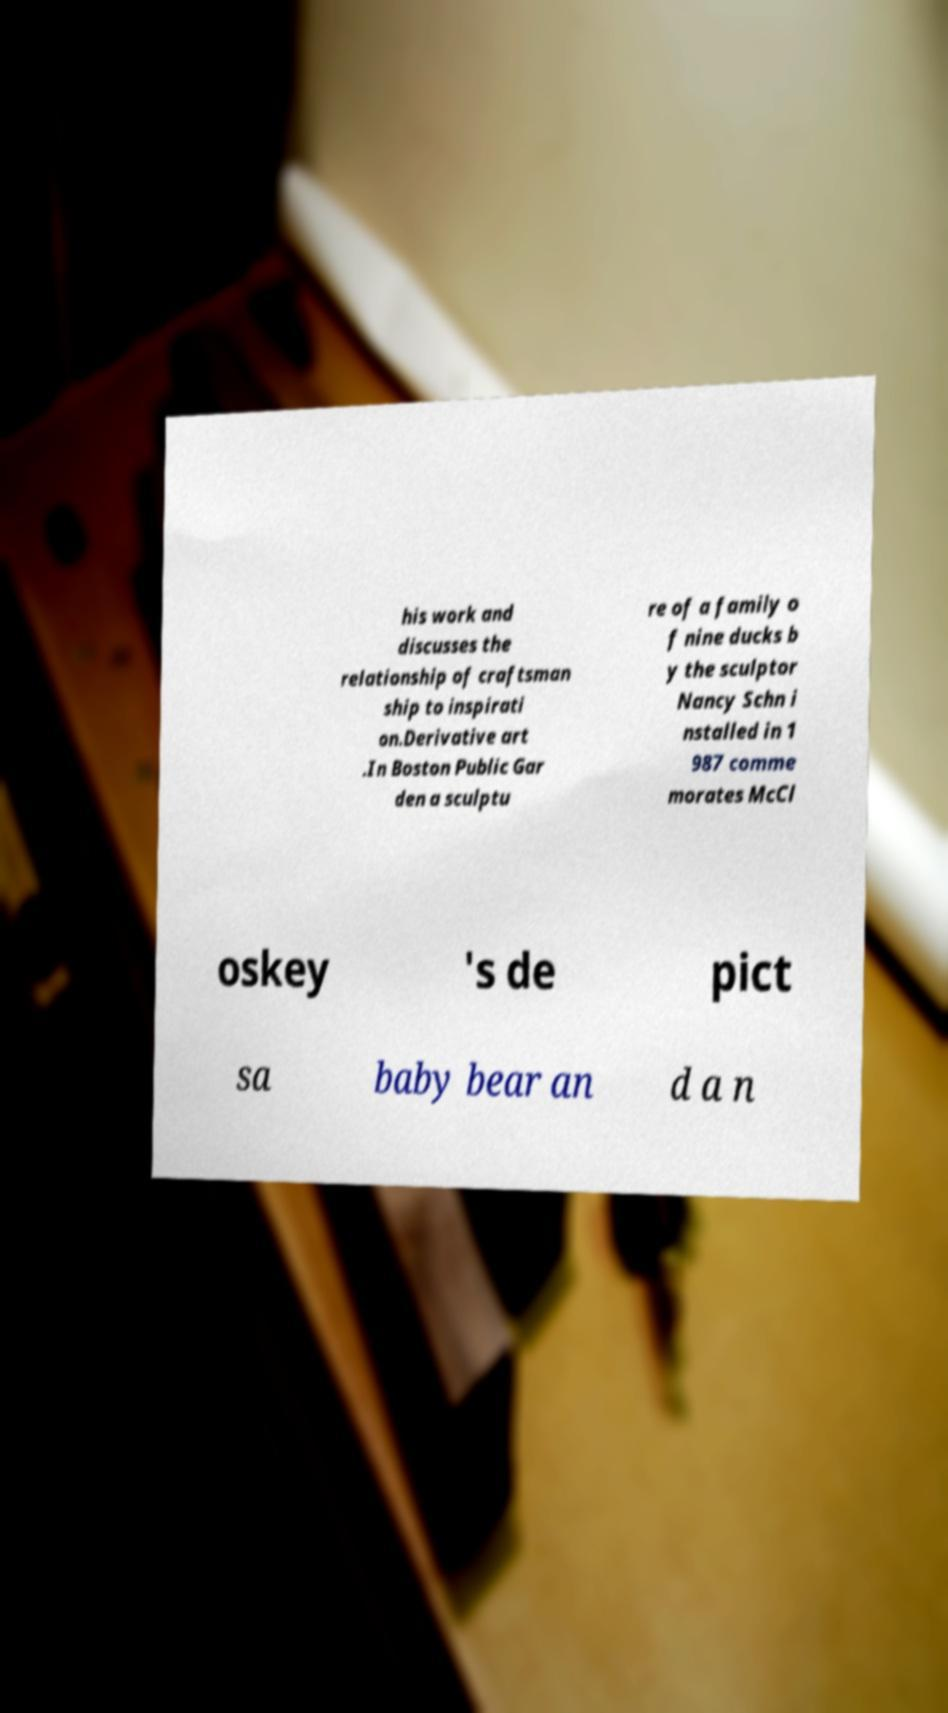There's text embedded in this image that I need extracted. Can you transcribe it verbatim? his work and discusses the relationship of craftsman ship to inspirati on.Derivative art .In Boston Public Gar den a sculptu re of a family o f nine ducks b y the sculptor Nancy Schn i nstalled in 1 987 comme morates McCl oskey 's de pict sa baby bear an d a n 